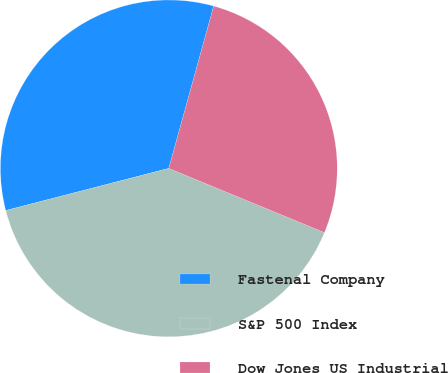Convert chart. <chart><loc_0><loc_0><loc_500><loc_500><pie_chart><fcel>Fastenal Company<fcel>S&P 500 Index<fcel>Dow Jones US Industrial<nl><fcel>33.32%<fcel>39.75%<fcel>26.93%<nl></chart> 